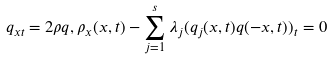Convert formula to latex. <formula><loc_0><loc_0><loc_500><loc_500>q _ { x t } = 2 \rho q , \rho _ { x } ( x , t ) - \sum _ { j = 1 } ^ { s } \lambda _ { j } ( q _ { j } ( x , t ) q ( - x , t ) ) _ { t } = 0</formula> 